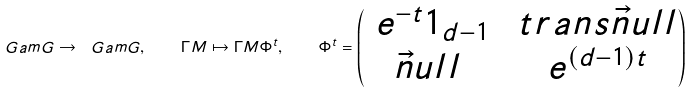<formula> <loc_0><loc_0><loc_500><loc_500>\ G a m G \to \ G a m G , \quad \Gamma M \mapsto \Gamma M \Phi ^ { t } , \quad \Phi ^ { t } = \begin{pmatrix} \ e ^ { - t } 1 _ { d - 1 } & \ t r a n s \vec { n } u l l \\ \vec { n } u l l & \ e ^ { ( d - 1 ) t } \end{pmatrix}</formula> 